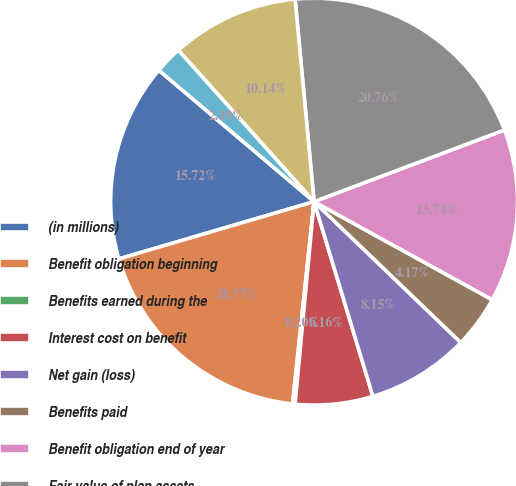Convert chart to OTSL. <chart><loc_0><loc_0><loc_500><loc_500><pie_chart><fcel>(in millions)<fcel>Benefit obligation beginning<fcel>Benefits earned during the<fcel>Interest cost on benefit<fcel>Net gain (loss)<fcel>Benefits paid<fcel>Benefit obligation end of year<fcel>Fair value of plan assets<fcel>Actual return on plan assets<fcel>Firm contributions<nl><fcel>15.72%<fcel>18.77%<fcel>0.2%<fcel>6.16%<fcel>8.15%<fcel>4.17%<fcel>13.74%<fcel>20.76%<fcel>10.14%<fcel>2.19%<nl></chart> 